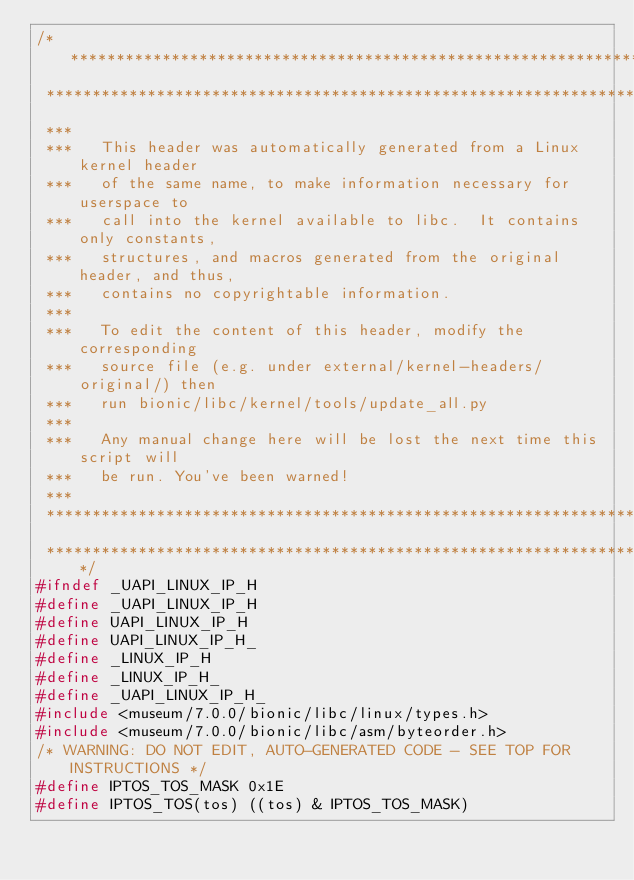Convert code to text. <code><loc_0><loc_0><loc_500><loc_500><_C_>/****************************************************************************
 ****************************************************************************
 ***
 ***   This header was automatically generated from a Linux kernel header
 ***   of the same name, to make information necessary for userspace to
 ***   call into the kernel available to libc.  It contains only constants,
 ***   structures, and macros generated from the original header, and thus,
 ***   contains no copyrightable information.
 ***
 ***   To edit the content of this header, modify the corresponding
 ***   source file (e.g. under external/kernel-headers/original/) then
 ***   run bionic/libc/kernel/tools/update_all.py
 ***
 ***   Any manual change here will be lost the next time this script will
 ***   be run. You've been warned!
 ***
 ****************************************************************************
 ****************************************************************************/
#ifndef _UAPI_LINUX_IP_H
#define _UAPI_LINUX_IP_H
#define UAPI_LINUX_IP_H
#define UAPI_LINUX_IP_H_
#define _LINUX_IP_H
#define _LINUX_IP_H_
#define _UAPI_LINUX_IP_H_
#include <museum/7.0.0/bionic/libc/linux/types.h>
#include <museum/7.0.0/bionic/libc/asm/byteorder.h>
/* WARNING: DO NOT EDIT, AUTO-GENERATED CODE - SEE TOP FOR INSTRUCTIONS */
#define IPTOS_TOS_MASK 0x1E
#define IPTOS_TOS(tos) ((tos) & IPTOS_TOS_MASK)</code> 